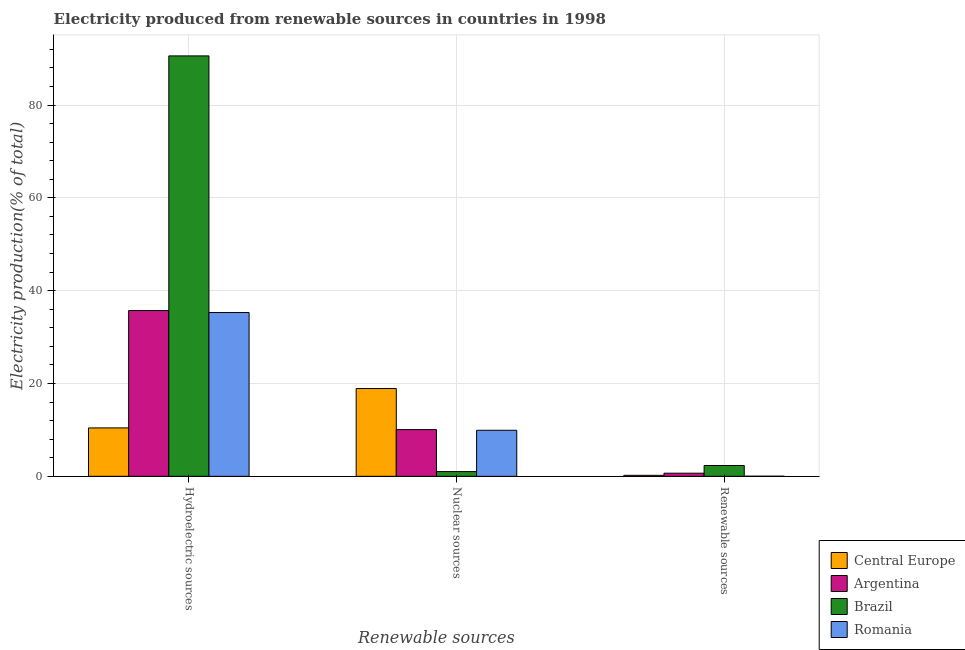How many different coloured bars are there?
Make the answer very short. 4. Are the number of bars per tick equal to the number of legend labels?
Your answer should be very brief. Yes. How many bars are there on the 3rd tick from the right?
Offer a terse response. 4. What is the label of the 3rd group of bars from the left?
Offer a very short reply. Renewable sources. What is the percentage of electricity produced by nuclear sources in Central Europe?
Your response must be concise. 18.91. Across all countries, what is the maximum percentage of electricity produced by nuclear sources?
Provide a succinct answer. 18.91. Across all countries, what is the minimum percentage of electricity produced by renewable sources?
Provide a succinct answer. 0.02. In which country was the percentage of electricity produced by renewable sources maximum?
Offer a very short reply. Brazil. In which country was the percentage of electricity produced by hydroelectric sources minimum?
Give a very brief answer. Central Europe. What is the total percentage of electricity produced by nuclear sources in the graph?
Make the answer very short. 39.92. What is the difference between the percentage of electricity produced by nuclear sources in Brazil and that in Romania?
Give a very brief answer. -8.91. What is the difference between the percentage of electricity produced by renewable sources in Central Europe and the percentage of electricity produced by nuclear sources in Argentina?
Offer a very short reply. -9.85. What is the average percentage of electricity produced by hydroelectric sources per country?
Your response must be concise. 43.01. What is the difference between the percentage of electricity produced by nuclear sources and percentage of electricity produced by renewable sources in Brazil?
Your answer should be very brief. -1.32. In how many countries, is the percentage of electricity produced by renewable sources greater than 68 %?
Provide a succinct answer. 0. What is the ratio of the percentage of electricity produced by nuclear sources in Romania to that in Brazil?
Your answer should be compact. 9.78. Is the difference between the percentage of electricity produced by hydroelectric sources in Brazil and Central Europe greater than the difference between the percentage of electricity produced by nuclear sources in Brazil and Central Europe?
Keep it short and to the point. Yes. What is the difference between the highest and the second highest percentage of electricity produced by hydroelectric sources?
Give a very brief answer. 54.87. What is the difference between the highest and the lowest percentage of electricity produced by nuclear sources?
Provide a short and direct response. 17.9. In how many countries, is the percentage of electricity produced by hydroelectric sources greater than the average percentage of electricity produced by hydroelectric sources taken over all countries?
Provide a short and direct response. 1. Is the sum of the percentage of electricity produced by nuclear sources in Romania and Argentina greater than the maximum percentage of electricity produced by renewable sources across all countries?
Make the answer very short. Yes. What does the 1st bar from the left in Renewable sources represents?
Offer a very short reply. Central Europe. What does the 4th bar from the right in Nuclear sources represents?
Your response must be concise. Central Europe. Are all the bars in the graph horizontal?
Give a very brief answer. No. What is the difference between two consecutive major ticks on the Y-axis?
Offer a terse response. 20. Are the values on the major ticks of Y-axis written in scientific E-notation?
Provide a succinct answer. No. Does the graph contain grids?
Offer a very short reply. Yes. Where does the legend appear in the graph?
Your response must be concise. Bottom right. What is the title of the graph?
Provide a short and direct response. Electricity produced from renewable sources in countries in 1998. Does "Zambia" appear as one of the legend labels in the graph?
Make the answer very short. No. What is the label or title of the X-axis?
Offer a very short reply. Renewable sources. What is the Electricity production(% of total) in Central Europe in Hydroelectric sources?
Give a very brief answer. 10.43. What is the Electricity production(% of total) of Argentina in Hydroelectric sources?
Keep it short and to the point. 35.72. What is the Electricity production(% of total) in Brazil in Hydroelectric sources?
Your answer should be very brief. 90.59. What is the Electricity production(% of total) of Romania in Hydroelectric sources?
Keep it short and to the point. 35.29. What is the Electricity production(% of total) of Central Europe in Nuclear sources?
Make the answer very short. 18.91. What is the Electricity production(% of total) in Argentina in Nuclear sources?
Give a very brief answer. 10.07. What is the Electricity production(% of total) of Brazil in Nuclear sources?
Ensure brevity in your answer.  1.01. What is the Electricity production(% of total) of Romania in Nuclear sources?
Offer a terse response. 9.92. What is the Electricity production(% of total) of Central Europe in Renewable sources?
Your answer should be compact. 0.22. What is the Electricity production(% of total) of Argentina in Renewable sources?
Provide a short and direct response. 0.67. What is the Electricity production(% of total) of Brazil in Renewable sources?
Offer a very short reply. 2.33. What is the Electricity production(% of total) in Romania in Renewable sources?
Give a very brief answer. 0.02. Across all Renewable sources, what is the maximum Electricity production(% of total) in Central Europe?
Provide a short and direct response. 18.91. Across all Renewable sources, what is the maximum Electricity production(% of total) in Argentina?
Ensure brevity in your answer.  35.72. Across all Renewable sources, what is the maximum Electricity production(% of total) of Brazil?
Your response must be concise. 90.59. Across all Renewable sources, what is the maximum Electricity production(% of total) in Romania?
Make the answer very short. 35.29. Across all Renewable sources, what is the minimum Electricity production(% of total) in Central Europe?
Your answer should be very brief. 0.22. Across all Renewable sources, what is the minimum Electricity production(% of total) of Argentina?
Give a very brief answer. 0.67. Across all Renewable sources, what is the minimum Electricity production(% of total) of Brazil?
Ensure brevity in your answer.  1.01. Across all Renewable sources, what is the minimum Electricity production(% of total) in Romania?
Your answer should be compact. 0.02. What is the total Electricity production(% of total) in Central Europe in the graph?
Your response must be concise. 29.56. What is the total Electricity production(% of total) of Argentina in the graph?
Your answer should be compact. 46.46. What is the total Electricity production(% of total) in Brazil in the graph?
Ensure brevity in your answer.  93.94. What is the total Electricity production(% of total) of Romania in the graph?
Your response must be concise. 45.23. What is the difference between the Electricity production(% of total) of Central Europe in Hydroelectric sources and that in Nuclear sources?
Offer a terse response. -8.48. What is the difference between the Electricity production(% of total) of Argentina in Hydroelectric sources and that in Nuclear sources?
Ensure brevity in your answer.  25.65. What is the difference between the Electricity production(% of total) in Brazil in Hydroelectric sources and that in Nuclear sources?
Keep it short and to the point. 89.57. What is the difference between the Electricity production(% of total) in Romania in Hydroelectric sources and that in Nuclear sources?
Provide a short and direct response. 25.37. What is the difference between the Electricity production(% of total) of Central Europe in Hydroelectric sources and that in Renewable sources?
Offer a terse response. 10.22. What is the difference between the Electricity production(% of total) of Argentina in Hydroelectric sources and that in Renewable sources?
Keep it short and to the point. 35.04. What is the difference between the Electricity production(% of total) of Brazil in Hydroelectric sources and that in Renewable sources?
Offer a very short reply. 88.26. What is the difference between the Electricity production(% of total) of Romania in Hydroelectric sources and that in Renewable sources?
Offer a terse response. 35.27. What is the difference between the Electricity production(% of total) of Central Europe in Nuclear sources and that in Renewable sources?
Provide a short and direct response. 18.7. What is the difference between the Electricity production(% of total) of Argentina in Nuclear sources and that in Renewable sources?
Ensure brevity in your answer.  9.4. What is the difference between the Electricity production(% of total) of Brazil in Nuclear sources and that in Renewable sources?
Your answer should be very brief. -1.32. What is the difference between the Electricity production(% of total) of Romania in Nuclear sources and that in Renewable sources?
Ensure brevity in your answer.  9.9. What is the difference between the Electricity production(% of total) in Central Europe in Hydroelectric sources and the Electricity production(% of total) in Argentina in Nuclear sources?
Your answer should be very brief. 0.36. What is the difference between the Electricity production(% of total) in Central Europe in Hydroelectric sources and the Electricity production(% of total) in Brazil in Nuclear sources?
Ensure brevity in your answer.  9.42. What is the difference between the Electricity production(% of total) of Central Europe in Hydroelectric sources and the Electricity production(% of total) of Romania in Nuclear sources?
Keep it short and to the point. 0.51. What is the difference between the Electricity production(% of total) of Argentina in Hydroelectric sources and the Electricity production(% of total) of Brazil in Nuclear sources?
Your answer should be very brief. 34.7. What is the difference between the Electricity production(% of total) in Argentina in Hydroelectric sources and the Electricity production(% of total) in Romania in Nuclear sources?
Ensure brevity in your answer.  25.8. What is the difference between the Electricity production(% of total) in Brazil in Hydroelectric sources and the Electricity production(% of total) in Romania in Nuclear sources?
Make the answer very short. 80.67. What is the difference between the Electricity production(% of total) in Central Europe in Hydroelectric sources and the Electricity production(% of total) in Argentina in Renewable sources?
Provide a succinct answer. 9.76. What is the difference between the Electricity production(% of total) of Central Europe in Hydroelectric sources and the Electricity production(% of total) of Brazil in Renewable sources?
Offer a terse response. 8.1. What is the difference between the Electricity production(% of total) of Central Europe in Hydroelectric sources and the Electricity production(% of total) of Romania in Renewable sources?
Provide a short and direct response. 10.41. What is the difference between the Electricity production(% of total) in Argentina in Hydroelectric sources and the Electricity production(% of total) in Brazil in Renewable sources?
Provide a succinct answer. 33.38. What is the difference between the Electricity production(% of total) in Argentina in Hydroelectric sources and the Electricity production(% of total) in Romania in Renewable sources?
Provide a succinct answer. 35.7. What is the difference between the Electricity production(% of total) of Brazil in Hydroelectric sources and the Electricity production(% of total) of Romania in Renewable sources?
Make the answer very short. 90.57. What is the difference between the Electricity production(% of total) of Central Europe in Nuclear sources and the Electricity production(% of total) of Argentina in Renewable sources?
Ensure brevity in your answer.  18.24. What is the difference between the Electricity production(% of total) in Central Europe in Nuclear sources and the Electricity production(% of total) in Brazil in Renewable sources?
Your answer should be very brief. 16.58. What is the difference between the Electricity production(% of total) in Central Europe in Nuclear sources and the Electricity production(% of total) in Romania in Renewable sources?
Ensure brevity in your answer.  18.89. What is the difference between the Electricity production(% of total) of Argentina in Nuclear sources and the Electricity production(% of total) of Brazil in Renewable sources?
Provide a short and direct response. 7.74. What is the difference between the Electricity production(% of total) of Argentina in Nuclear sources and the Electricity production(% of total) of Romania in Renewable sources?
Offer a very short reply. 10.05. What is the average Electricity production(% of total) in Central Europe per Renewable sources?
Make the answer very short. 9.85. What is the average Electricity production(% of total) in Argentina per Renewable sources?
Your answer should be very brief. 15.49. What is the average Electricity production(% of total) in Brazil per Renewable sources?
Offer a terse response. 31.31. What is the average Electricity production(% of total) of Romania per Renewable sources?
Ensure brevity in your answer.  15.08. What is the difference between the Electricity production(% of total) of Central Europe and Electricity production(% of total) of Argentina in Hydroelectric sources?
Your response must be concise. -25.29. What is the difference between the Electricity production(% of total) of Central Europe and Electricity production(% of total) of Brazil in Hydroelectric sources?
Your answer should be very brief. -80.16. What is the difference between the Electricity production(% of total) of Central Europe and Electricity production(% of total) of Romania in Hydroelectric sources?
Give a very brief answer. -24.86. What is the difference between the Electricity production(% of total) in Argentina and Electricity production(% of total) in Brazil in Hydroelectric sources?
Offer a terse response. -54.87. What is the difference between the Electricity production(% of total) in Argentina and Electricity production(% of total) in Romania in Hydroelectric sources?
Offer a terse response. 0.43. What is the difference between the Electricity production(% of total) of Brazil and Electricity production(% of total) of Romania in Hydroelectric sources?
Ensure brevity in your answer.  55.3. What is the difference between the Electricity production(% of total) of Central Europe and Electricity production(% of total) of Argentina in Nuclear sources?
Provide a short and direct response. 8.84. What is the difference between the Electricity production(% of total) in Central Europe and Electricity production(% of total) in Brazil in Nuclear sources?
Give a very brief answer. 17.9. What is the difference between the Electricity production(% of total) of Central Europe and Electricity production(% of total) of Romania in Nuclear sources?
Provide a succinct answer. 8.99. What is the difference between the Electricity production(% of total) of Argentina and Electricity production(% of total) of Brazil in Nuclear sources?
Give a very brief answer. 9.06. What is the difference between the Electricity production(% of total) in Argentina and Electricity production(% of total) in Romania in Nuclear sources?
Offer a terse response. 0.15. What is the difference between the Electricity production(% of total) in Brazil and Electricity production(% of total) in Romania in Nuclear sources?
Provide a short and direct response. -8.91. What is the difference between the Electricity production(% of total) in Central Europe and Electricity production(% of total) in Argentina in Renewable sources?
Ensure brevity in your answer.  -0.46. What is the difference between the Electricity production(% of total) of Central Europe and Electricity production(% of total) of Brazil in Renewable sources?
Provide a short and direct response. -2.12. What is the difference between the Electricity production(% of total) in Central Europe and Electricity production(% of total) in Romania in Renewable sources?
Your response must be concise. 0.2. What is the difference between the Electricity production(% of total) of Argentina and Electricity production(% of total) of Brazil in Renewable sources?
Provide a short and direct response. -1.66. What is the difference between the Electricity production(% of total) of Argentina and Electricity production(% of total) of Romania in Renewable sources?
Your answer should be compact. 0.65. What is the difference between the Electricity production(% of total) in Brazil and Electricity production(% of total) in Romania in Renewable sources?
Provide a succinct answer. 2.31. What is the ratio of the Electricity production(% of total) of Central Europe in Hydroelectric sources to that in Nuclear sources?
Provide a succinct answer. 0.55. What is the ratio of the Electricity production(% of total) of Argentina in Hydroelectric sources to that in Nuclear sources?
Your answer should be compact. 3.55. What is the ratio of the Electricity production(% of total) in Brazil in Hydroelectric sources to that in Nuclear sources?
Provide a short and direct response. 89.27. What is the ratio of the Electricity production(% of total) of Romania in Hydroelectric sources to that in Nuclear sources?
Keep it short and to the point. 3.56. What is the ratio of the Electricity production(% of total) of Central Europe in Hydroelectric sources to that in Renewable sources?
Make the answer very short. 48.34. What is the ratio of the Electricity production(% of total) of Argentina in Hydroelectric sources to that in Renewable sources?
Offer a very short reply. 53.08. What is the ratio of the Electricity production(% of total) in Brazil in Hydroelectric sources to that in Renewable sources?
Ensure brevity in your answer.  38.81. What is the ratio of the Electricity production(% of total) in Romania in Hydroelectric sources to that in Renewable sources?
Your response must be concise. 1716.27. What is the ratio of the Electricity production(% of total) of Central Europe in Nuclear sources to that in Renewable sources?
Offer a terse response. 87.65. What is the ratio of the Electricity production(% of total) in Argentina in Nuclear sources to that in Renewable sources?
Offer a very short reply. 14.97. What is the ratio of the Electricity production(% of total) of Brazil in Nuclear sources to that in Renewable sources?
Offer a very short reply. 0.43. What is the ratio of the Electricity production(% of total) in Romania in Nuclear sources to that in Renewable sources?
Provide a succinct answer. 482.45. What is the difference between the highest and the second highest Electricity production(% of total) of Central Europe?
Keep it short and to the point. 8.48. What is the difference between the highest and the second highest Electricity production(% of total) of Argentina?
Give a very brief answer. 25.65. What is the difference between the highest and the second highest Electricity production(% of total) in Brazil?
Provide a short and direct response. 88.26. What is the difference between the highest and the second highest Electricity production(% of total) of Romania?
Keep it short and to the point. 25.37. What is the difference between the highest and the lowest Electricity production(% of total) of Central Europe?
Your response must be concise. 18.7. What is the difference between the highest and the lowest Electricity production(% of total) of Argentina?
Give a very brief answer. 35.04. What is the difference between the highest and the lowest Electricity production(% of total) of Brazil?
Provide a succinct answer. 89.57. What is the difference between the highest and the lowest Electricity production(% of total) in Romania?
Provide a short and direct response. 35.27. 